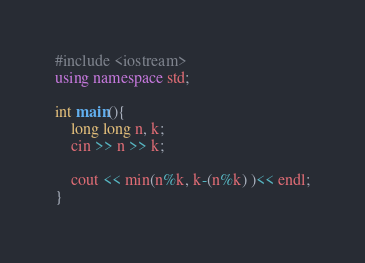Convert code to text. <code><loc_0><loc_0><loc_500><loc_500><_C++_>#include <iostream>
using namespace std;

int main(){
    long long n, k;
    cin >> n >> k;

    cout << min(n%k, k-(n%k) )<< endl;
}</code> 